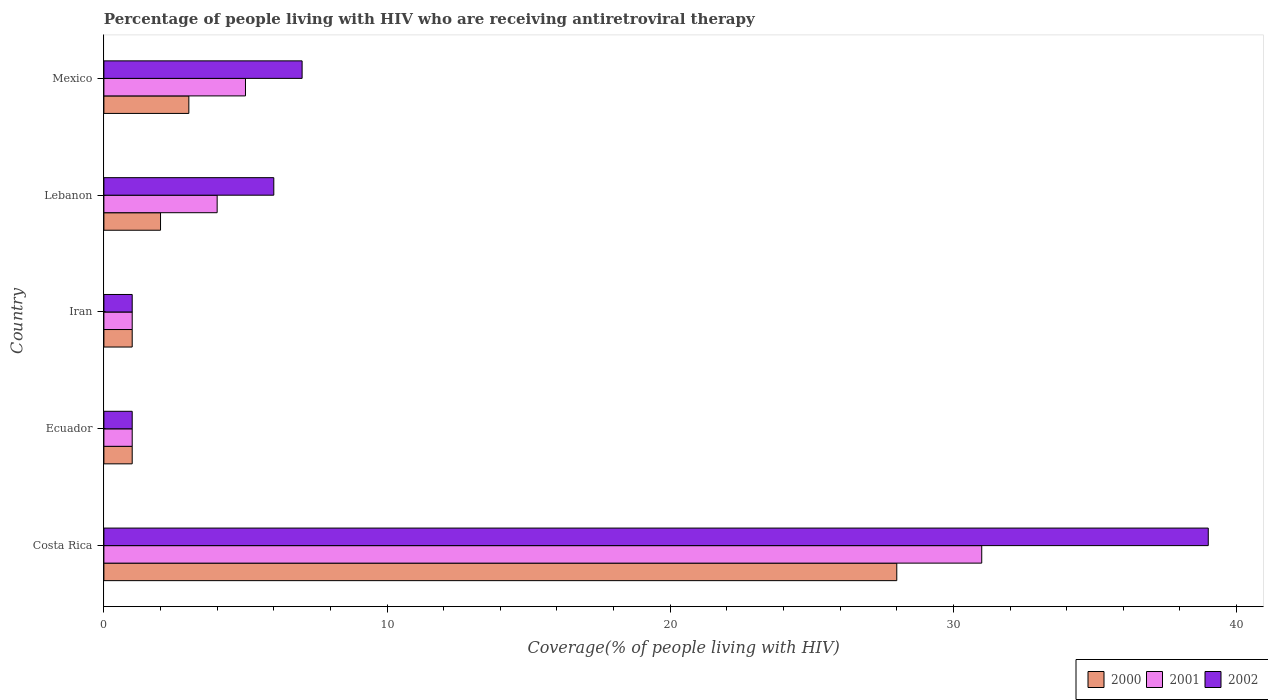How many different coloured bars are there?
Keep it short and to the point. 3. How many groups of bars are there?
Provide a short and direct response. 5. Are the number of bars per tick equal to the number of legend labels?
Ensure brevity in your answer.  Yes. Are the number of bars on each tick of the Y-axis equal?
Offer a terse response. Yes. How many bars are there on the 3rd tick from the top?
Offer a terse response. 3. What is the label of the 4th group of bars from the top?
Keep it short and to the point. Ecuador. Across all countries, what is the maximum percentage of the HIV infected people who are receiving antiretroviral therapy in 2002?
Keep it short and to the point. 39. Across all countries, what is the minimum percentage of the HIV infected people who are receiving antiretroviral therapy in 2001?
Ensure brevity in your answer.  1. In which country was the percentage of the HIV infected people who are receiving antiretroviral therapy in 2000 minimum?
Your answer should be very brief. Ecuador. What is the difference between the percentage of the HIV infected people who are receiving antiretroviral therapy in 2000 in Iran and that in Mexico?
Make the answer very short. -2. In how many countries, is the percentage of the HIV infected people who are receiving antiretroviral therapy in 2002 greater than 26 %?
Make the answer very short. 1. Is the difference between the percentage of the HIV infected people who are receiving antiretroviral therapy in 2002 in Ecuador and Mexico greater than the difference between the percentage of the HIV infected people who are receiving antiretroviral therapy in 2001 in Ecuador and Mexico?
Keep it short and to the point. No. In how many countries, is the percentage of the HIV infected people who are receiving antiretroviral therapy in 2000 greater than the average percentage of the HIV infected people who are receiving antiretroviral therapy in 2000 taken over all countries?
Make the answer very short. 1. Is the sum of the percentage of the HIV infected people who are receiving antiretroviral therapy in 2001 in Costa Rica and Mexico greater than the maximum percentage of the HIV infected people who are receiving antiretroviral therapy in 2000 across all countries?
Keep it short and to the point. Yes. What does the 2nd bar from the top in Lebanon represents?
Give a very brief answer. 2001. What does the 3rd bar from the bottom in Mexico represents?
Keep it short and to the point. 2002. Is it the case that in every country, the sum of the percentage of the HIV infected people who are receiving antiretroviral therapy in 2002 and percentage of the HIV infected people who are receiving antiretroviral therapy in 2001 is greater than the percentage of the HIV infected people who are receiving antiretroviral therapy in 2000?
Give a very brief answer. Yes. How many bars are there?
Ensure brevity in your answer.  15. Are all the bars in the graph horizontal?
Give a very brief answer. Yes. How many countries are there in the graph?
Offer a terse response. 5. What is the difference between two consecutive major ticks on the X-axis?
Provide a short and direct response. 10. Are the values on the major ticks of X-axis written in scientific E-notation?
Provide a succinct answer. No. Does the graph contain any zero values?
Keep it short and to the point. No. Where does the legend appear in the graph?
Give a very brief answer. Bottom right. What is the title of the graph?
Your response must be concise. Percentage of people living with HIV who are receiving antiretroviral therapy. Does "1985" appear as one of the legend labels in the graph?
Your response must be concise. No. What is the label or title of the X-axis?
Offer a terse response. Coverage(% of people living with HIV). What is the label or title of the Y-axis?
Provide a short and direct response. Country. What is the Coverage(% of people living with HIV) of 2000 in Costa Rica?
Provide a short and direct response. 28. What is the Coverage(% of people living with HIV) in 2001 in Costa Rica?
Provide a succinct answer. 31. What is the Coverage(% of people living with HIV) in 2002 in Costa Rica?
Give a very brief answer. 39. What is the Coverage(% of people living with HIV) of 2001 in Ecuador?
Offer a very short reply. 1. What is the Coverage(% of people living with HIV) in 2002 in Ecuador?
Your response must be concise. 1. What is the Coverage(% of people living with HIV) in 2002 in Iran?
Your answer should be compact. 1. What is the Coverage(% of people living with HIV) of 2002 in Lebanon?
Your response must be concise. 6. What is the Coverage(% of people living with HIV) in 2002 in Mexico?
Make the answer very short. 7. Across all countries, what is the maximum Coverage(% of people living with HIV) in 2000?
Provide a short and direct response. 28. Across all countries, what is the maximum Coverage(% of people living with HIV) of 2001?
Make the answer very short. 31. Across all countries, what is the maximum Coverage(% of people living with HIV) in 2002?
Make the answer very short. 39. Across all countries, what is the minimum Coverage(% of people living with HIV) in 2000?
Your answer should be very brief. 1. Across all countries, what is the minimum Coverage(% of people living with HIV) of 2002?
Make the answer very short. 1. What is the total Coverage(% of people living with HIV) of 2001 in the graph?
Your answer should be compact. 42. What is the difference between the Coverage(% of people living with HIV) in 2000 in Costa Rica and that in Iran?
Your answer should be very brief. 27. What is the difference between the Coverage(% of people living with HIV) of 2001 in Costa Rica and that in Iran?
Offer a terse response. 30. What is the difference between the Coverage(% of people living with HIV) in 2000 in Costa Rica and that in Mexico?
Keep it short and to the point. 25. What is the difference between the Coverage(% of people living with HIV) in 2001 in Costa Rica and that in Mexico?
Give a very brief answer. 26. What is the difference between the Coverage(% of people living with HIV) in 2002 in Costa Rica and that in Mexico?
Offer a very short reply. 32. What is the difference between the Coverage(% of people living with HIV) in 2002 in Ecuador and that in Iran?
Your answer should be compact. 0. What is the difference between the Coverage(% of people living with HIV) in 2001 in Ecuador and that in Lebanon?
Your answer should be very brief. -3. What is the difference between the Coverage(% of people living with HIV) in 2002 in Ecuador and that in Lebanon?
Ensure brevity in your answer.  -5. What is the difference between the Coverage(% of people living with HIV) of 2000 in Ecuador and that in Mexico?
Give a very brief answer. -2. What is the difference between the Coverage(% of people living with HIV) of 2000 in Iran and that in Lebanon?
Your response must be concise. -1. What is the difference between the Coverage(% of people living with HIV) of 2001 in Iran and that in Lebanon?
Give a very brief answer. -3. What is the difference between the Coverage(% of people living with HIV) in 2001 in Iran and that in Mexico?
Your response must be concise. -4. What is the difference between the Coverage(% of people living with HIV) of 2000 in Lebanon and that in Mexico?
Offer a terse response. -1. What is the difference between the Coverage(% of people living with HIV) of 2001 in Lebanon and that in Mexico?
Give a very brief answer. -1. What is the difference between the Coverage(% of people living with HIV) in 2002 in Lebanon and that in Mexico?
Your response must be concise. -1. What is the difference between the Coverage(% of people living with HIV) of 2001 in Costa Rica and the Coverage(% of people living with HIV) of 2002 in Ecuador?
Ensure brevity in your answer.  30. What is the difference between the Coverage(% of people living with HIV) of 2000 in Costa Rica and the Coverage(% of people living with HIV) of 2002 in Iran?
Offer a very short reply. 27. What is the difference between the Coverage(% of people living with HIV) in 2001 in Costa Rica and the Coverage(% of people living with HIV) in 2002 in Iran?
Provide a short and direct response. 30. What is the difference between the Coverage(% of people living with HIV) in 2000 in Costa Rica and the Coverage(% of people living with HIV) in 2002 in Lebanon?
Offer a very short reply. 22. What is the difference between the Coverage(% of people living with HIV) of 2000 in Costa Rica and the Coverage(% of people living with HIV) of 2001 in Mexico?
Make the answer very short. 23. What is the difference between the Coverage(% of people living with HIV) of 2001 in Costa Rica and the Coverage(% of people living with HIV) of 2002 in Mexico?
Give a very brief answer. 24. What is the difference between the Coverage(% of people living with HIV) in 2000 in Ecuador and the Coverage(% of people living with HIV) in 2002 in Iran?
Offer a very short reply. 0. What is the difference between the Coverage(% of people living with HIV) of 2000 in Ecuador and the Coverage(% of people living with HIV) of 2001 in Lebanon?
Ensure brevity in your answer.  -3. What is the difference between the Coverage(% of people living with HIV) of 2000 in Ecuador and the Coverage(% of people living with HIV) of 2002 in Mexico?
Make the answer very short. -6. What is the difference between the Coverage(% of people living with HIV) in 2001 in Ecuador and the Coverage(% of people living with HIV) in 2002 in Mexico?
Your response must be concise. -6. What is the difference between the Coverage(% of people living with HIV) in 2000 in Iran and the Coverage(% of people living with HIV) in 2001 in Lebanon?
Provide a short and direct response. -3. What is the difference between the Coverage(% of people living with HIV) in 2000 in Iran and the Coverage(% of people living with HIV) in 2002 in Lebanon?
Provide a succinct answer. -5. What is the difference between the Coverage(% of people living with HIV) in 2001 in Iran and the Coverage(% of people living with HIV) in 2002 in Mexico?
Ensure brevity in your answer.  -6. What is the difference between the Coverage(% of people living with HIV) of 2000 in Lebanon and the Coverage(% of people living with HIV) of 2001 in Mexico?
Your answer should be very brief. -3. What is the difference between the Coverage(% of people living with HIV) of 2000 in Lebanon and the Coverage(% of people living with HIV) of 2002 in Mexico?
Your answer should be very brief. -5. What is the average Coverage(% of people living with HIV) in 2002 per country?
Provide a succinct answer. 10.8. What is the difference between the Coverage(% of people living with HIV) of 2000 and Coverage(% of people living with HIV) of 2002 in Costa Rica?
Give a very brief answer. -11. What is the difference between the Coverage(% of people living with HIV) in 2001 and Coverage(% of people living with HIV) in 2002 in Costa Rica?
Offer a very short reply. -8. What is the difference between the Coverage(% of people living with HIV) in 2000 and Coverage(% of people living with HIV) in 2001 in Ecuador?
Give a very brief answer. 0. What is the difference between the Coverage(% of people living with HIV) in 2000 and Coverage(% of people living with HIV) in 2001 in Iran?
Your response must be concise. 0. What is the difference between the Coverage(% of people living with HIV) in 2000 and Coverage(% of people living with HIV) in 2001 in Lebanon?
Provide a short and direct response. -2. What is the difference between the Coverage(% of people living with HIV) of 2000 and Coverage(% of people living with HIV) of 2001 in Mexico?
Provide a succinct answer. -2. What is the difference between the Coverage(% of people living with HIV) of 2000 and Coverage(% of people living with HIV) of 2002 in Mexico?
Provide a succinct answer. -4. What is the ratio of the Coverage(% of people living with HIV) of 2001 in Costa Rica to that in Ecuador?
Offer a terse response. 31. What is the ratio of the Coverage(% of people living with HIV) of 2000 in Costa Rica to that in Lebanon?
Keep it short and to the point. 14. What is the ratio of the Coverage(% of people living with HIV) in 2001 in Costa Rica to that in Lebanon?
Offer a very short reply. 7.75. What is the ratio of the Coverage(% of people living with HIV) in 2000 in Costa Rica to that in Mexico?
Your response must be concise. 9.33. What is the ratio of the Coverage(% of people living with HIV) of 2001 in Costa Rica to that in Mexico?
Your answer should be compact. 6.2. What is the ratio of the Coverage(% of people living with HIV) in 2002 in Costa Rica to that in Mexico?
Provide a succinct answer. 5.57. What is the ratio of the Coverage(% of people living with HIV) of 2002 in Ecuador to that in Iran?
Your answer should be compact. 1. What is the ratio of the Coverage(% of people living with HIV) of 2002 in Ecuador to that in Lebanon?
Provide a short and direct response. 0.17. What is the ratio of the Coverage(% of people living with HIV) in 2001 in Ecuador to that in Mexico?
Your response must be concise. 0.2. What is the ratio of the Coverage(% of people living with HIV) in 2002 in Ecuador to that in Mexico?
Make the answer very short. 0.14. What is the ratio of the Coverage(% of people living with HIV) in 2000 in Iran to that in Lebanon?
Your response must be concise. 0.5. What is the ratio of the Coverage(% of people living with HIV) in 2001 in Iran to that in Lebanon?
Your answer should be very brief. 0.25. What is the ratio of the Coverage(% of people living with HIV) of 2000 in Iran to that in Mexico?
Offer a terse response. 0.33. What is the ratio of the Coverage(% of people living with HIV) in 2001 in Iran to that in Mexico?
Provide a short and direct response. 0.2. What is the ratio of the Coverage(% of people living with HIV) of 2002 in Iran to that in Mexico?
Make the answer very short. 0.14. What is the ratio of the Coverage(% of people living with HIV) in 2000 in Lebanon to that in Mexico?
Make the answer very short. 0.67. What is the ratio of the Coverage(% of people living with HIV) in 2001 in Lebanon to that in Mexico?
Provide a succinct answer. 0.8. What is the ratio of the Coverage(% of people living with HIV) of 2002 in Lebanon to that in Mexico?
Ensure brevity in your answer.  0.86. What is the difference between the highest and the second highest Coverage(% of people living with HIV) in 2001?
Give a very brief answer. 26. What is the difference between the highest and the lowest Coverage(% of people living with HIV) in 2002?
Your answer should be compact. 38. 